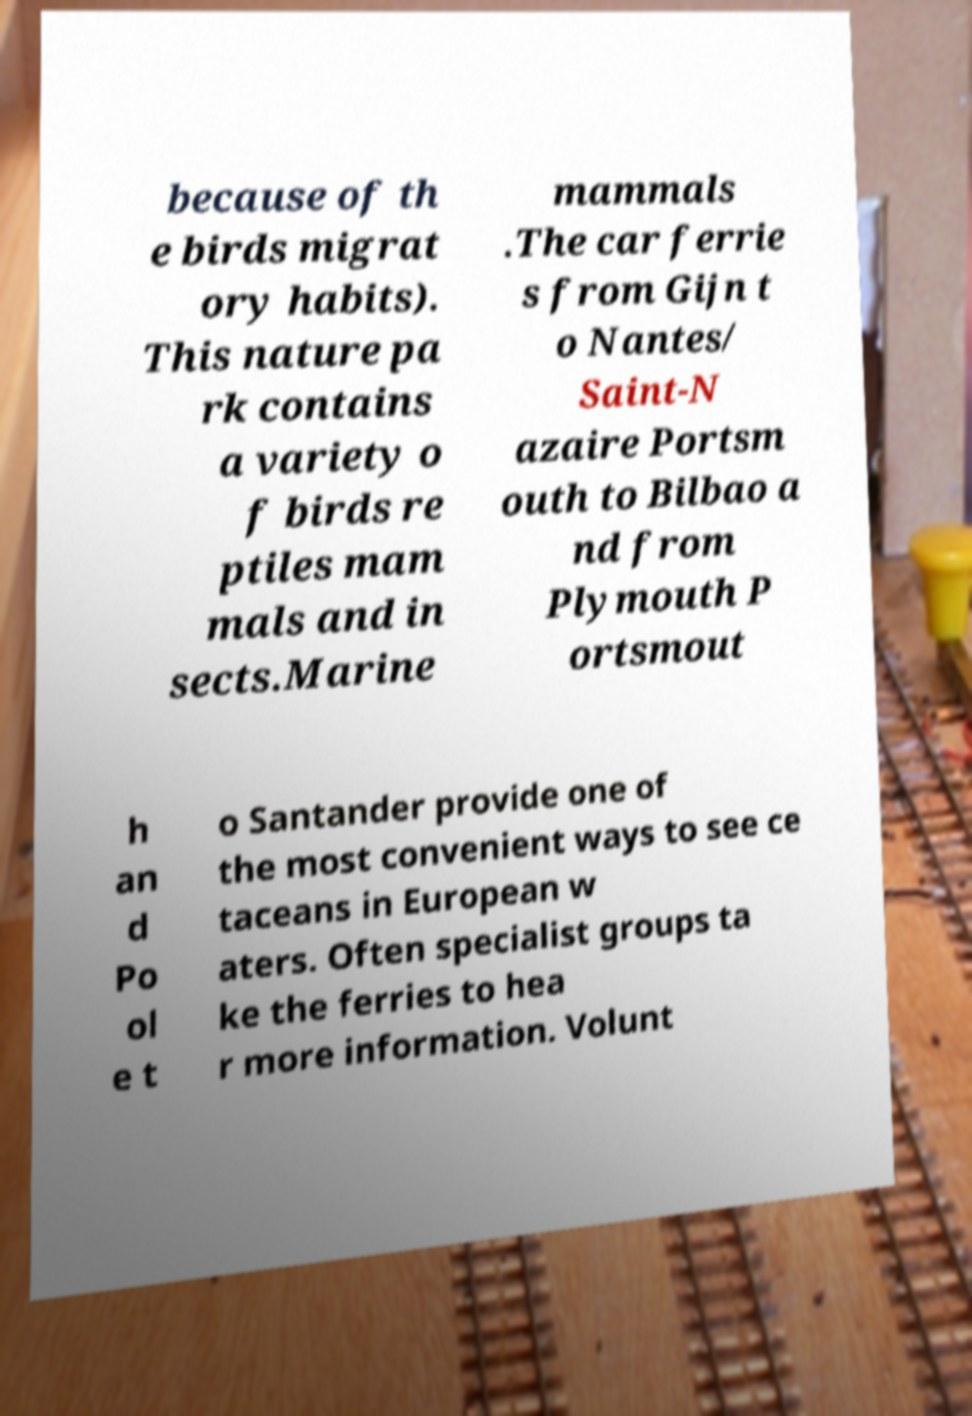What messages or text are displayed in this image? I need them in a readable, typed format. because of th e birds migrat ory habits). This nature pa rk contains a variety o f birds re ptiles mam mals and in sects.Marine mammals .The car ferrie s from Gijn t o Nantes/ Saint-N azaire Portsm outh to Bilbao a nd from Plymouth P ortsmout h an d Po ol e t o Santander provide one of the most convenient ways to see ce taceans in European w aters. Often specialist groups ta ke the ferries to hea r more information. Volunt 